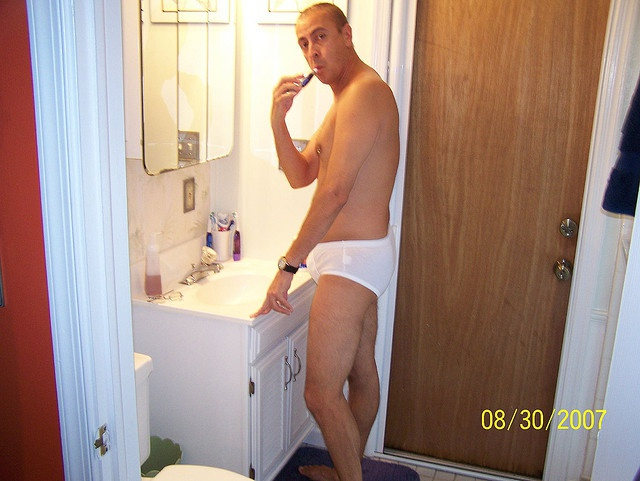Describe the objects in this image and their specific colors. I can see people in maroon, brown, tan, and lightgray tones, toilet in maroon, beige, darkgray, tan, and lightgray tones, sink in maroon, beige, tan, and salmon tones, bottle in maroon, brown, tan, and lightgray tones, and toothbrush in maroon, brown, purple, violet, and darkgray tones in this image. 